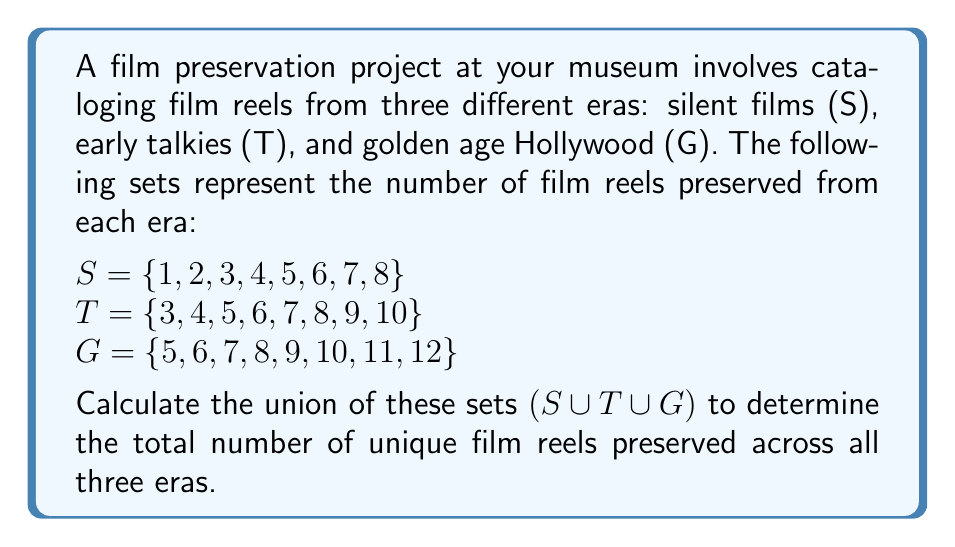Teach me how to tackle this problem. To calculate the union of these three sets, we need to identify all unique elements that appear in at least one of the sets. Let's approach this step-by-step:

1) First, let's list out all the elements in each set:
   $S = \{1, 2, 3, 4, 5, 6, 7, 8\}$
   $T = \{3, 4, 5, 6, 7, 8, 9, 10\}$
   $G = \{5, 6, 7, 8, 9, 10, 11, 12\}$

2) Now, let's combine all these elements, keeping only one instance of each number:
   $S \cup T \cup G = \{1, 2, 3, 4, 5, 6, 7, 8, 9, 10, 11, 12\}$

3) We can see that:
   - 1 and 2 appear only in S
   - 3 and 4 appear in S and T
   - 5, 6, 7, and 8 appear in all three sets
   - 9 and 10 appear in T and G
   - 11 and 12 appear only in G

4) To count the total number of unique elements, we simply need to count the elements in our union set:
   $|S \cup T \cup G| = 12$

Therefore, there are 12 unique film reels preserved across all three eras.
Answer: $|S \cup T \cup G| = 12$ 